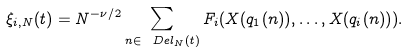<formula> <loc_0><loc_0><loc_500><loc_500>\xi _ { i , N } ( t ) = N ^ { - \nu / 2 } \sum _ { n \in \ D e l _ { N } ( t ) } F _ { i } ( X ( q _ { 1 } ( n ) ) , \dots , X ( q _ { i } ( n ) ) ) .</formula> 